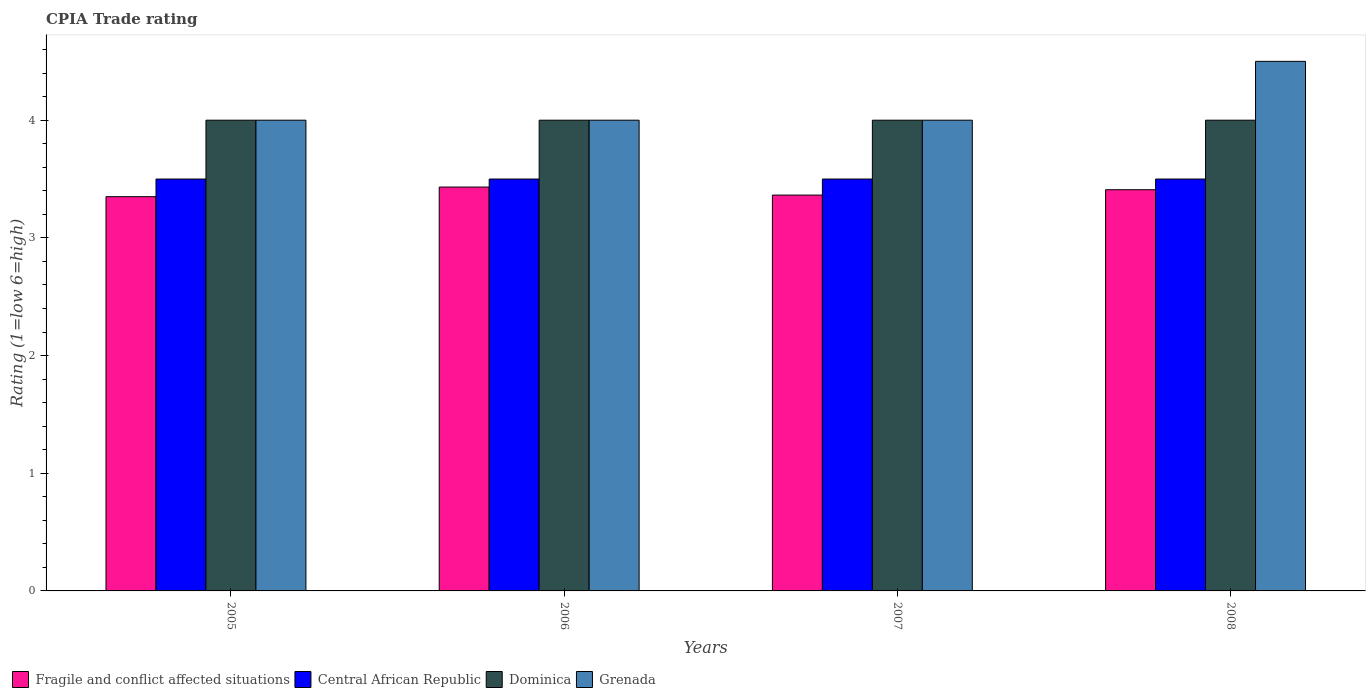How many different coloured bars are there?
Make the answer very short. 4. Are the number of bars on each tick of the X-axis equal?
Your answer should be compact. Yes. How many bars are there on the 1st tick from the left?
Provide a succinct answer. 4. How many bars are there on the 2nd tick from the right?
Your answer should be very brief. 4. What is the label of the 2nd group of bars from the left?
Your answer should be very brief. 2006. In how many cases, is the number of bars for a given year not equal to the number of legend labels?
Offer a very short reply. 0. What is the CPIA rating in Grenada in 2007?
Your answer should be very brief. 4. Across all years, what is the minimum CPIA rating in Grenada?
Offer a very short reply. 4. In which year was the CPIA rating in Grenada maximum?
Your answer should be very brief. 2008. What is the total CPIA rating in Fragile and conflict affected situations in the graph?
Ensure brevity in your answer.  13.55. What is the difference between the CPIA rating in Fragile and conflict affected situations in 2005 and that in 2006?
Your answer should be compact. -0.08. What is the difference between the CPIA rating in Fragile and conflict affected situations in 2008 and the CPIA rating in Central African Republic in 2006?
Your answer should be compact. -0.09. What is the average CPIA rating in Fragile and conflict affected situations per year?
Provide a short and direct response. 3.39. What is the ratio of the CPIA rating in Fragile and conflict affected situations in 2005 to that in 2006?
Offer a terse response. 0.98. What is the difference between the highest and the second highest CPIA rating in Fragile and conflict affected situations?
Offer a very short reply. 0.02. What is the difference between the highest and the lowest CPIA rating in Central African Republic?
Offer a very short reply. 0. In how many years, is the CPIA rating in Grenada greater than the average CPIA rating in Grenada taken over all years?
Ensure brevity in your answer.  1. Is the sum of the CPIA rating in Central African Republic in 2005 and 2007 greater than the maximum CPIA rating in Fragile and conflict affected situations across all years?
Keep it short and to the point. Yes. Is it the case that in every year, the sum of the CPIA rating in Central African Republic and CPIA rating in Dominica is greater than the sum of CPIA rating in Grenada and CPIA rating in Fragile and conflict affected situations?
Your answer should be very brief. Yes. What does the 2nd bar from the left in 2005 represents?
Keep it short and to the point. Central African Republic. What does the 3rd bar from the right in 2005 represents?
Your answer should be very brief. Central African Republic. Are all the bars in the graph horizontal?
Ensure brevity in your answer.  No. How many years are there in the graph?
Your response must be concise. 4. What is the difference between two consecutive major ticks on the Y-axis?
Provide a short and direct response. 1. Where does the legend appear in the graph?
Provide a short and direct response. Bottom left. How many legend labels are there?
Give a very brief answer. 4. How are the legend labels stacked?
Give a very brief answer. Horizontal. What is the title of the graph?
Provide a short and direct response. CPIA Trade rating. Does "San Marino" appear as one of the legend labels in the graph?
Keep it short and to the point. No. What is the label or title of the X-axis?
Make the answer very short. Years. What is the label or title of the Y-axis?
Your answer should be very brief. Rating (1=low 6=high). What is the Rating (1=low 6=high) of Fragile and conflict affected situations in 2005?
Provide a succinct answer. 3.35. What is the Rating (1=low 6=high) of Fragile and conflict affected situations in 2006?
Your response must be concise. 3.43. What is the Rating (1=low 6=high) of Dominica in 2006?
Provide a short and direct response. 4. What is the Rating (1=low 6=high) of Grenada in 2006?
Your answer should be very brief. 4. What is the Rating (1=low 6=high) of Fragile and conflict affected situations in 2007?
Provide a short and direct response. 3.36. What is the Rating (1=low 6=high) in Central African Republic in 2007?
Provide a short and direct response. 3.5. What is the Rating (1=low 6=high) in Dominica in 2007?
Your response must be concise. 4. What is the Rating (1=low 6=high) of Fragile and conflict affected situations in 2008?
Offer a very short reply. 3.41. What is the Rating (1=low 6=high) in Central African Republic in 2008?
Keep it short and to the point. 3.5. What is the Rating (1=low 6=high) in Dominica in 2008?
Offer a very short reply. 4. Across all years, what is the maximum Rating (1=low 6=high) in Fragile and conflict affected situations?
Your response must be concise. 3.43. Across all years, what is the maximum Rating (1=low 6=high) in Central African Republic?
Your answer should be compact. 3.5. Across all years, what is the maximum Rating (1=low 6=high) of Dominica?
Make the answer very short. 4. Across all years, what is the minimum Rating (1=low 6=high) in Fragile and conflict affected situations?
Your answer should be very brief. 3.35. Across all years, what is the minimum Rating (1=low 6=high) in Central African Republic?
Your response must be concise. 3.5. Across all years, what is the minimum Rating (1=low 6=high) of Dominica?
Give a very brief answer. 4. Across all years, what is the minimum Rating (1=low 6=high) of Grenada?
Keep it short and to the point. 4. What is the total Rating (1=low 6=high) in Fragile and conflict affected situations in the graph?
Make the answer very short. 13.55. What is the total Rating (1=low 6=high) in Central African Republic in the graph?
Your answer should be very brief. 14. What is the total Rating (1=low 6=high) of Dominica in the graph?
Provide a short and direct response. 16. What is the difference between the Rating (1=low 6=high) of Fragile and conflict affected situations in 2005 and that in 2006?
Provide a succinct answer. -0.08. What is the difference between the Rating (1=low 6=high) of Central African Republic in 2005 and that in 2006?
Provide a succinct answer. 0. What is the difference between the Rating (1=low 6=high) in Grenada in 2005 and that in 2006?
Ensure brevity in your answer.  0. What is the difference between the Rating (1=low 6=high) of Fragile and conflict affected situations in 2005 and that in 2007?
Provide a short and direct response. -0.01. What is the difference between the Rating (1=low 6=high) of Central African Republic in 2005 and that in 2007?
Keep it short and to the point. 0. What is the difference between the Rating (1=low 6=high) in Grenada in 2005 and that in 2007?
Make the answer very short. 0. What is the difference between the Rating (1=low 6=high) in Fragile and conflict affected situations in 2005 and that in 2008?
Provide a succinct answer. -0.06. What is the difference between the Rating (1=low 6=high) in Central African Republic in 2005 and that in 2008?
Your answer should be compact. 0. What is the difference between the Rating (1=low 6=high) of Dominica in 2005 and that in 2008?
Offer a terse response. 0. What is the difference between the Rating (1=low 6=high) of Fragile and conflict affected situations in 2006 and that in 2007?
Offer a terse response. 0.07. What is the difference between the Rating (1=low 6=high) in Dominica in 2006 and that in 2007?
Ensure brevity in your answer.  0. What is the difference between the Rating (1=low 6=high) in Fragile and conflict affected situations in 2006 and that in 2008?
Your answer should be compact. 0.02. What is the difference between the Rating (1=low 6=high) in Dominica in 2006 and that in 2008?
Provide a succinct answer. 0. What is the difference between the Rating (1=low 6=high) of Grenada in 2006 and that in 2008?
Your answer should be compact. -0.5. What is the difference between the Rating (1=low 6=high) in Fragile and conflict affected situations in 2007 and that in 2008?
Make the answer very short. -0.05. What is the difference between the Rating (1=low 6=high) in Dominica in 2007 and that in 2008?
Offer a very short reply. 0. What is the difference between the Rating (1=low 6=high) of Fragile and conflict affected situations in 2005 and the Rating (1=low 6=high) of Dominica in 2006?
Offer a very short reply. -0.65. What is the difference between the Rating (1=low 6=high) of Fragile and conflict affected situations in 2005 and the Rating (1=low 6=high) of Grenada in 2006?
Provide a succinct answer. -0.65. What is the difference between the Rating (1=low 6=high) in Central African Republic in 2005 and the Rating (1=low 6=high) in Dominica in 2006?
Provide a short and direct response. -0.5. What is the difference between the Rating (1=low 6=high) in Central African Republic in 2005 and the Rating (1=low 6=high) in Grenada in 2006?
Give a very brief answer. -0.5. What is the difference between the Rating (1=low 6=high) of Dominica in 2005 and the Rating (1=low 6=high) of Grenada in 2006?
Your answer should be very brief. 0. What is the difference between the Rating (1=low 6=high) of Fragile and conflict affected situations in 2005 and the Rating (1=low 6=high) of Central African Republic in 2007?
Provide a short and direct response. -0.15. What is the difference between the Rating (1=low 6=high) in Fragile and conflict affected situations in 2005 and the Rating (1=low 6=high) in Dominica in 2007?
Your answer should be very brief. -0.65. What is the difference between the Rating (1=low 6=high) in Fragile and conflict affected situations in 2005 and the Rating (1=low 6=high) in Grenada in 2007?
Provide a short and direct response. -0.65. What is the difference between the Rating (1=low 6=high) of Central African Republic in 2005 and the Rating (1=low 6=high) of Dominica in 2007?
Ensure brevity in your answer.  -0.5. What is the difference between the Rating (1=low 6=high) of Central African Republic in 2005 and the Rating (1=low 6=high) of Grenada in 2007?
Offer a very short reply. -0.5. What is the difference between the Rating (1=low 6=high) of Dominica in 2005 and the Rating (1=low 6=high) of Grenada in 2007?
Your response must be concise. 0. What is the difference between the Rating (1=low 6=high) of Fragile and conflict affected situations in 2005 and the Rating (1=low 6=high) of Central African Republic in 2008?
Provide a succinct answer. -0.15. What is the difference between the Rating (1=low 6=high) of Fragile and conflict affected situations in 2005 and the Rating (1=low 6=high) of Dominica in 2008?
Keep it short and to the point. -0.65. What is the difference between the Rating (1=low 6=high) of Fragile and conflict affected situations in 2005 and the Rating (1=low 6=high) of Grenada in 2008?
Provide a short and direct response. -1.15. What is the difference between the Rating (1=low 6=high) of Central African Republic in 2005 and the Rating (1=low 6=high) of Grenada in 2008?
Ensure brevity in your answer.  -1. What is the difference between the Rating (1=low 6=high) in Fragile and conflict affected situations in 2006 and the Rating (1=low 6=high) in Central African Republic in 2007?
Provide a succinct answer. -0.07. What is the difference between the Rating (1=low 6=high) of Fragile and conflict affected situations in 2006 and the Rating (1=low 6=high) of Dominica in 2007?
Your answer should be very brief. -0.57. What is the difference between the Rating (1=low 6=high) in Fragile and conflict affected situations in 2006 and the Rating (1=low 6=high) in Grenada in 2007?
Provide a succinct answer. -0.57. What is the difference between the Rating (1=low 6=high) of Central African Republic in 2006 and the Rating (1=low 6=high) of Dominica in 2007?
Offer a very short reply. -0.5. What is the difference between the Rating (1=low 6=high) of Central African Republic in 2006 and the Rating (1=low 6=high) of Grenada in 2007?
Offer a terse response. -0.5. What is the difference between the Rating (1=low 6=high) in Fragile and conflict affected situations in 2006 and the Rating (1=low 6=high) in Central African Republic in 2008?
Keep it short and to the point. -0.07. What is the difference between the Rating (1=low 6=high) of Fragile and conflict affected situations in 2006 and the Rating (1=low 6=high) of Dominica in 2008?
Your response must be concise. -0.57. What is the difference between the Rating (1=low 6=high) of Fragile and conflict affected situations in 2006 and the Rating (1=low 6=high) of Grenada in 2008?
Provide a succinct answer. -1.07. What is the difference between the Rating (1=low 6=high) of Central African Republic in 2006 and the Rating (1=low 6=high) of Dominica in 2008?
Give a very brief answer. -0.5. What is the difference between the Rating (1=low 6=high) of Dominica in 2006 and the Rating (1=low 6=high) of Grenada in 2008?
Give a very brief answer. -0.5. What is the difference between the Rating (1=low 6=high) of Fragile and conflict affected situations in 2007 and the Rating (1=low 6=high) of Central African Republic in 2008?
Provide a succinct answer. -0.14. What is the difference between the Rating (1=low 6=high) of Fragile and conflict affected situations in 2007 and the Rating (1=low 6=high) of Dominica in 2008?
Your response must be concise. -0.64. What is the difference between the Rating (1=low 6=high) of Fragile and conflict affected situations in 2007 and the Rating (1=low 6=high) of Grenada in 2008?
Offer a very short reply. -1.14. What is the difference between the Rating (1=low 6=high) in Central African Republic in 2007 and the Rating (1=low 6=high) in Dominica in 2008?
Provide a succinct answer. -0.5. What is the average Rating (1=low 6=high) in Fragile and conflict affected situations per year?
Offer a terse response. 3.39. What is the average Rating (1=low 6=high) of Grenada per year?
Give a very brief answer. 4.12. In the year 2005, what is the difference between the Rating (1=low 6=high) in Fragile and conflict affected situations and Rating (1=low 6=high) in Dominica?
Ensure brevity in your answer.  -0.65. In the year 2005, what is the difference between the Rating (1=low 6=high) in Fragile and conflict affected situations and Rating (1=low 6=high) in Grenada?
Your response must be concise. -0.65. In the year 2005, what is the difference between the Rating (1=low 6=high) in Central African Republic and Rating (1=low 6=high) in Dominica?
Provide a succinct answer. -0.5. In the year 2005, what is the difference between the Rating (1=low 6=high) in Dominica and Rating (1=low 6=high) in Grenada?
Your answer should be very brief. 0. In the year 2006, what is the difference between the Rating (1=low 6=high) in Fragile and conflict affected situations and Rating (1=low 6=high) in Central African Republic?
Your response must be concise. -0.07. In the year 2006, what is the difference between the Rating (1=low 6=high) of Fragile and conflict affected situations and Rating (1=low 6=high) of Dominica?
Offer a very short reply. -0.57. In the year 2006, what is the difference between the Rating (1=low 6=high) in Fragile and conflict affected situations and Rating (1=low 6=high) in Grenada?
Provide a short and direct response. -0.57. In the year 2006, what is the difference between the Rating (1=low 6=high) of Central African Republic and Rating (1=low 6=high) of Dominica?
Your response must be concise. -0.5. In the year 2006, what is the difference between the Rating (1=low 6=high) in Dominica and Rating (1=low 6=high) in Grenada?
Provide a succinct answer. 0. In the year 2007, what is the difference between the Rating (1=low 6=high) in Fragile and conflict affected situations and Rating (1=low 6=high) in Central African Republic?
Your answer should be compact. -0.14. In the year 2007, what is the difference between the Rating (1=low 6=high) in Fragile and conflict affected situations and Rating (1=low 6=high) in Dominica?
Give a very brief answer. -0.64. In the year 2007, what is the difference between the Rating (1=low 6=high) of Fragile and conflict affected situations and Rating (1=low 6=high) of Grenada?
Your response must be concise. -0.64. In the year 2007, what is the difference between the Rating (1=low 6=high) in Central African Republic and Rating (1=low 6=high) in Dominica?
Give a very brief answer. -0.5. In the year 2007, what is the difference between the Rating (1=low 6=high) in Central African Republic and Rating (1=low 6=high) in Grenada?
Make the answer very short. -0.5. In the year 2007, what is the difference between the Rating (1=low 6=high) in Dominica and Rating (1=low 6=high) in Grenada?
Provide a succinct answer. 0. In the year 2008, what is the difference between the Rating (1=low 6=high) of Fragile and conflict affected situations and Rating (1=low 6=high) of Central African Republic?
Your response must be concise. -0.09. In the year 2008, what is the difference between the Rating (1=low 6=high) in Fragile and conflict affected situations and Rating (1=low 6=high) in Dominica?
Your response must be concise. -0.59. In the year 2008, what is the difference between the Rating (1=low 6=high) in Fragile and conflict affected situations and Rating (1=low 6=high) in Grenada?
Your answer should be very brief. -1.09. In the year 2008, what is the difference between the Rating (1=low 6=high) in Central African Republic and Rating (1=low 6=high) in Dominica?
Provide a succinct answer. -0.5. In the year 2008, what is the difference between the Rating (1=low 6=high) of Central African Republic and Rating (1=low 6=high) of Grenada?
Make the answer very short. -1. In the year 2008, what is the difference between the Rating (1=low 6=high) of Dominica and Rating (1=low 6=high) of Grenada?
Provide a short and direct response. -0.5. What is the ratio of the Rating (1=low 6=high) of Fragile and conflict affected situations in 2005 to that in 2006?
Keep it short and to the point. 0.98. What is the ratio of the Rating (1=low 6=high) of Central African Republic in 2005 to that in 2006?
Give a very brief answer. 1. What is the ratio of the Rating (1=low 6=high) of Grenada in 2005 to that in 2006?
Give a very brief answer. 1. What is the ratio of the Rating (1=low 6=high) in Fragile and conflict affected situations in 2005 to that in 2008?
Ensure brevity in your answer.  0.98. What is the ratio of the Rating (1=low 6=high) in Central African Republic in 2005 to that in 2008?
Your answer should be compact. 1. What is the ratio of the Rating (1=low 6=high) of Dominica in 2005 to that in 2008?
Provide a succinct answer. 1. What is the ratio of the Rating (1=low 6=high) in Fragile and conflict affected situations in 2006 to that in 2007?
Your response must be concise. 1.02. What is the ratio of the Rating (1=low 6=high) of Dominica in 2006 to that in 2007?
Ensure brevity in your answer.  1. What is the ratio of the Rating (1=low 6=high) in Fragile and conflict affected situations in 2006 to that in 2008?
Offer a very short reply. 1.01. What is the ratio of the Rating (1=low 6=high) in Central African Republic in 2006 to that in 2008?
Your answer should be very brief. 1. What is the ratio of the Rating (1=low 6=high) of Grenada in 2006 to that in 2008?
Provide a short and direct response. 0.89. What is the ratio of the Rating (1=low 6=high) of Fragile and conflict affected situations in 2007 to that in 2008?
Offer a terse response. 0.99. What is the difference between the highest and the second highest Rating (1=low 6=high) in Fragile and conflict affected situations?
Ensure brevity in your answer.  0.02. What is the difference between the highest and the second highest Rating (1=low 6=high) in Grenada?
Offer a terse response. 0.5. What is the difference between the highest and the lowest Rating (1=low 6=high) in Fragile and conflict affected situations?
Offer a very short reply. 0.08. 